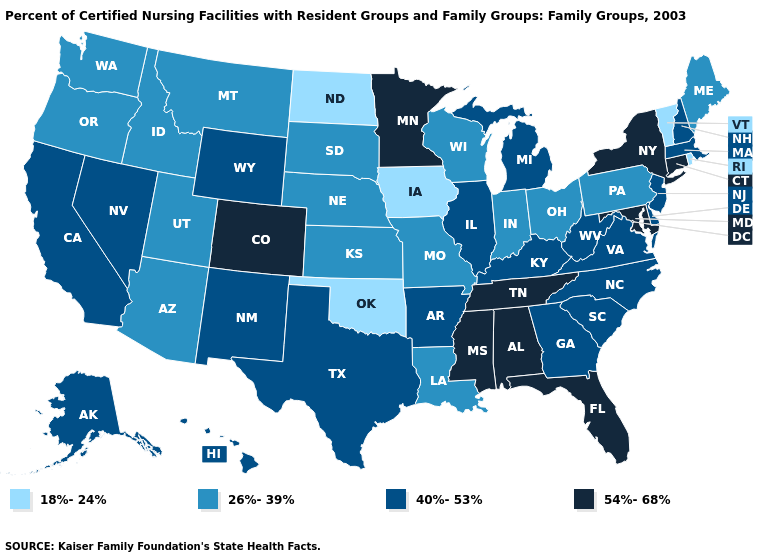What is the value of Maryland?
Keep it brief. 54%-68%. Does the first symbol in the legend represent the smallest category?
Be succinct. Yes. Does the first symbol in the legend represent the smallest category?
Write a very short answer. Yes. Name the states that have a value in the range 40%-53%?
Concise answer only. Alaska, Arkansas, California, Delaware, Georgia, Hawaii, Illinois, Kentucky, Massachusetts, Michigan, Nevada, New Hampshire, New Jersey, New Mexico, North Carolina, South Carolina, Texas, Virginia, West Virginia, Wyoming. What is the value of Nebraska?
Quick response, please. 26%-39%. Which states have the lowest value in the MidWest?
Quick response, please. Iowa, North Dakota. What is the value of Oklahoma?
Write a very short answer. 18%-24%. What is the value of Florida?
Short answer required. 54%-68%. What is the value of Massachusetts?
Give a very brief answer. 40%-53%. What is the highest value in the South ?
Write a very short answer. 54%-68%. What is the value of Florida?
Be succinct. 54%-68%. Among the states that border Virginia , does Maryland have the highest value?
Give a very brief answer. Yes. Does Rhode Island have the lowest value in the Northeast?
Concise answer only. Yes. Among the states that border Connecticut , does New York have the highest value?
Quick response, please. Yes. Does the first symbol in the legend represent the smallest category?
Short answer required. Yes. 